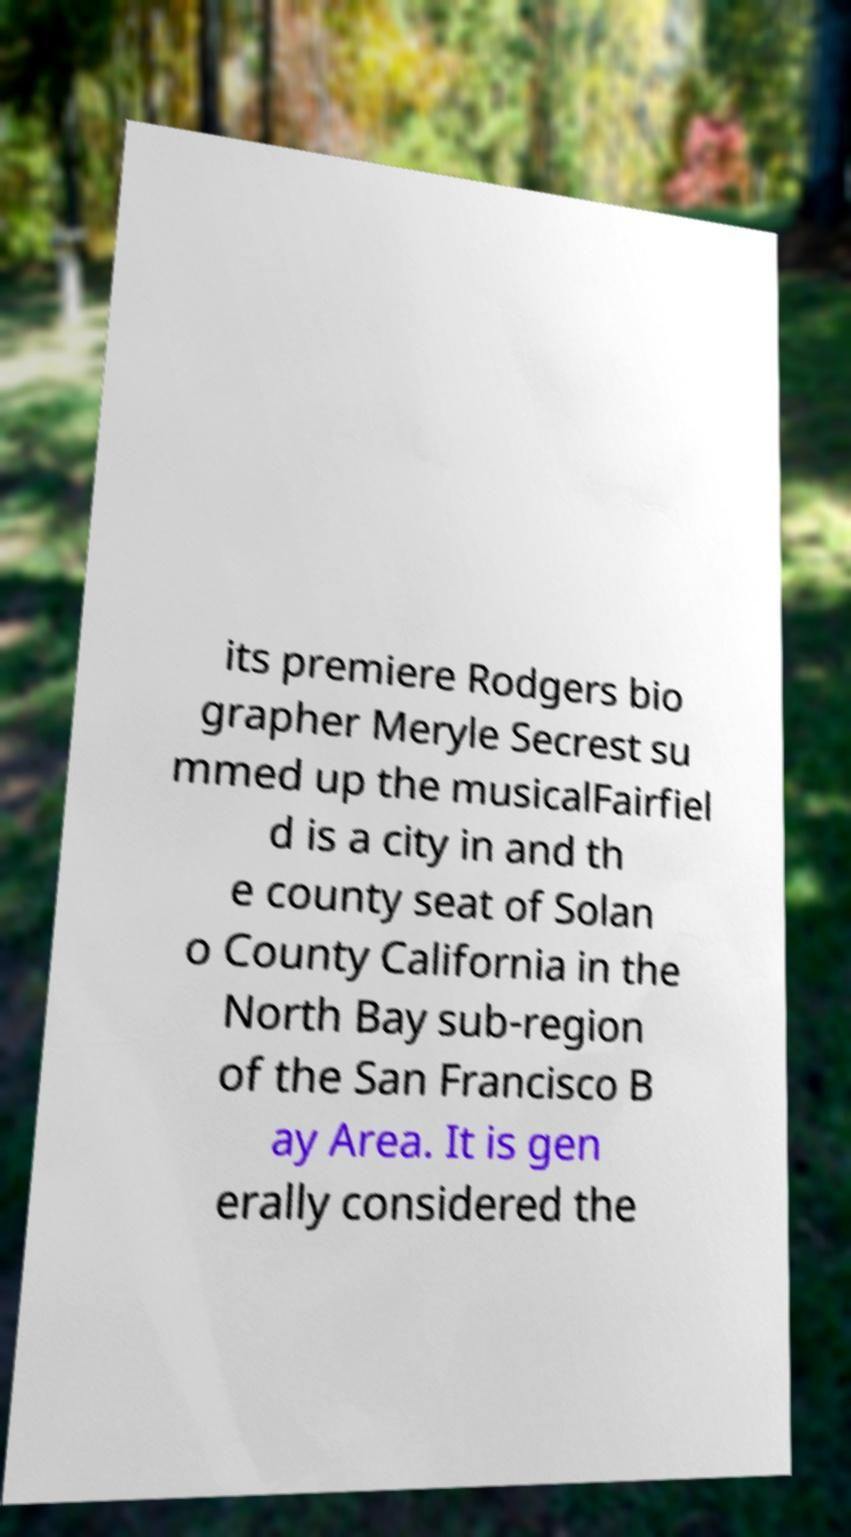What messages or text are displayed in this image? I need them in a readable, typed format. its premiere Rodgers bio grapher Meryle Secrest su mmed up the musicalFairfiel d is a city in and th e county seat of Solan o County California in the North Bay sub-region of the San Francisco B ay Area. It is gen erally considered the 